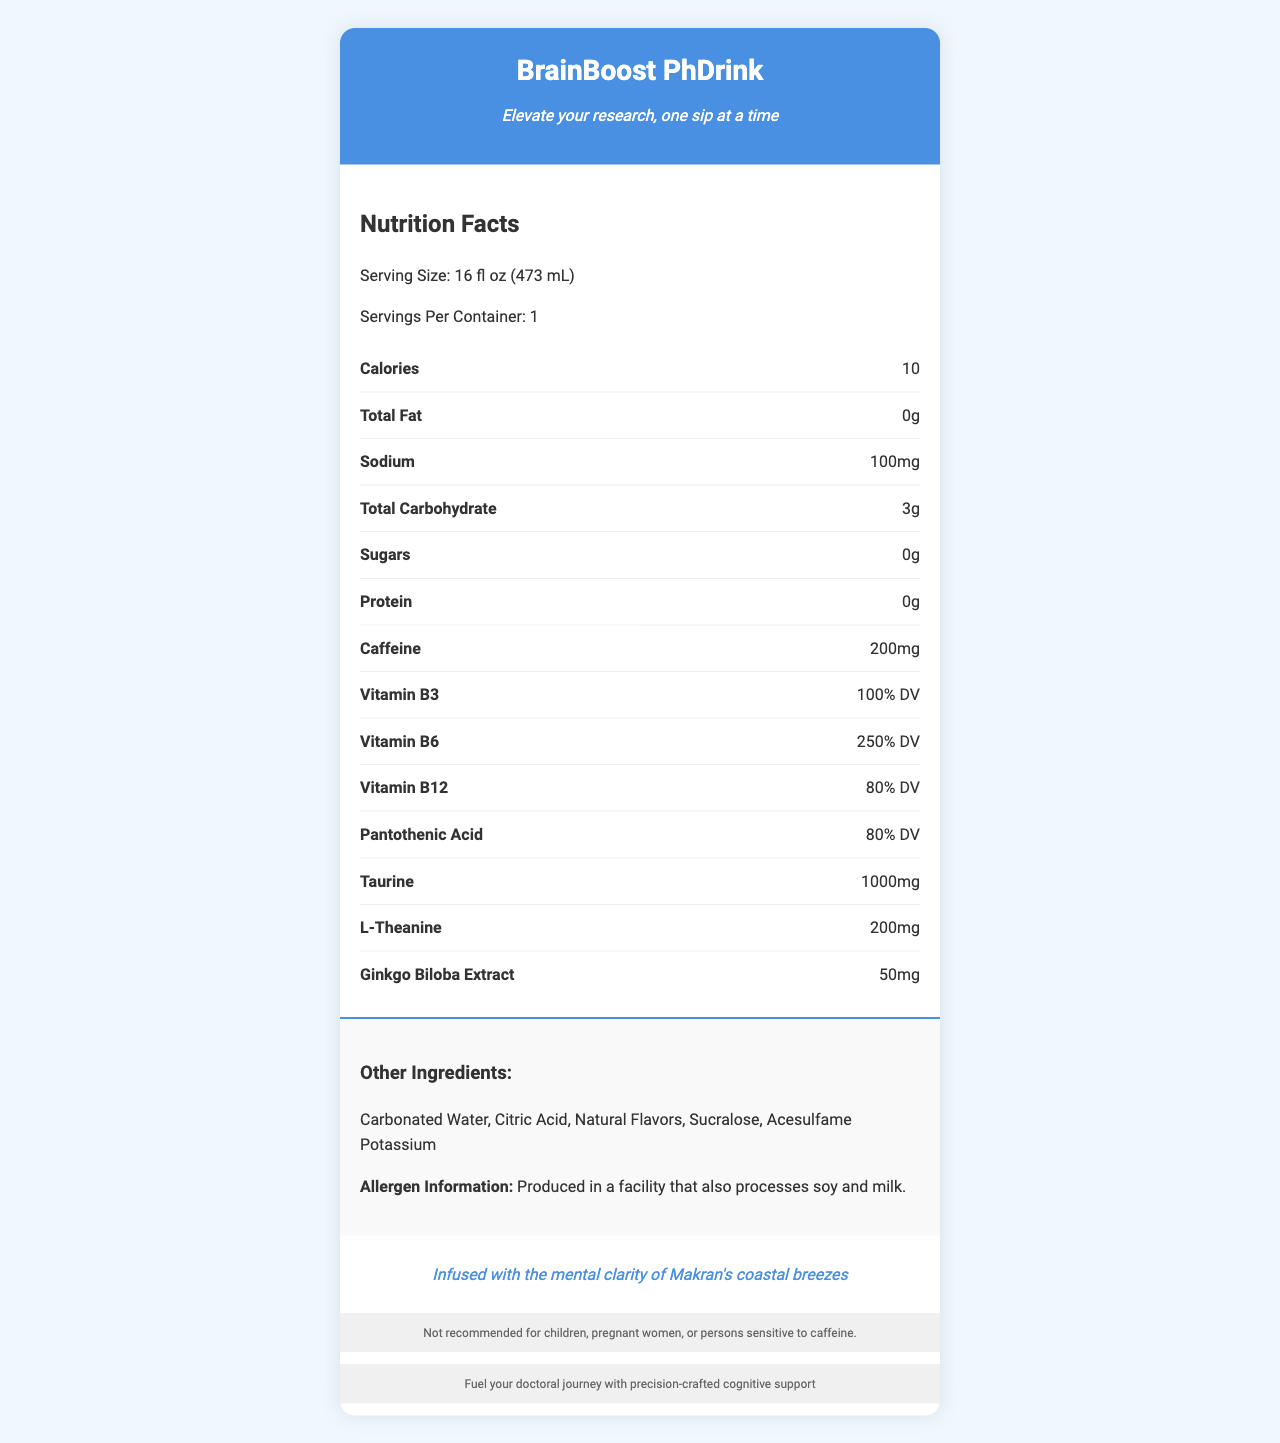what is the product name? The product name is clearly stated at the top of the document.
Answer: BrainBoost PhDrink how many servings are in one container? The document lists "Servings Per Container: 1".
Answer: 1 how much caffeine does one serving contain? Under the "Nutrition Facts", it is mentioned that there are "200mg" of caffeine.
Answer: 200mg what is the serving size for this product? The serving size is specified as "16 fl oz (473 mL)".
Answer: 16 fl oz (473 mL) what percentage of the daily value of Vitamin B6 does the product provide? The document states "Vitamin B6: 250% DV".
Answer: 250% how many calories are in one serving? The document lists "Calories: 10".
Answer: 10 what are the main ingredients in the product? The "Other Ingredients" section lists these ingredients.
Answer: Carbonated Water, Citric Acid, Natural Flavors, Sucralose, Acesulfame Potassium is this product recommended for children? The disclaimer at the bottom states "Not recommended for children".
Answer: No what are the vitamin B3 and B12 percentages of the daily value in this product? Both percentages are listed in the "Nutrition Facts" section.
Answer: Vitamin B3: 100% DV, Vitamin B12: 80% DV what should you be aware of regarding allergens? The allergen information specifies this under "Allergen Information".
Answer: Produced in a facility that also processes soy and milk. what unique ingredient is included in the product for mental clarity? The document lists "Ginkgo Biloba Extract" under the "Nutrition Facts".
Answer: Ginkgo Biloba Extract based on the document, who is the product marketed towards? The document includes marketing phrases such as "Fuel your doctoral journey with precision-crafted cognitive support".
Answer: PhD students what is the tagline of BrainBoost PhDrink? The tagline is written directly under the product name in the header.
Answer: Elevate your research, one sip at a time what is the unique element inspired by Makran culture in this product? This is mentioned as the "Makran Inspiration" at the bottom of the document.
Answer: Infused with the mental clarity of Makran's coastal breezes which of the following is not listed as an ingredient in BrainBoost PhDrink? A. Carbonated Water B. Sucralose C. High Fructose Corn Syrup D. Acesulfame Potassium High Fructose Corn Syrup is not listed in the "Other Ingredients" section.
Answer: C. High Fructose Corn Syrup how much sodium does one serving contain? A. 50mg B. 100mg C. 150mg D. 200mg It is listed as "Sodium: 100mg" in the "Nutrition Facts".
Answer: B. 100mg how would you summarize the main idea of this document? The document highlights the product's name, serving details, key ingredients, and marketing targeted towards doctoral students for mental clarity and support.
Answer: BrainBoost PhDrink is an energy drink designed to support PhD students with cognitive-enhancing ingredients like caffeine, B-vitamins, and Ginkgo Biloba Extract. It boasts low calories and zero sugars, providing focused energy "one sip at a time". did the document provide information on how to purchase the product? There is no information in the document about purchasing the product.
Answer: No how much taurine is included in each serving? The amount of taurine is specified as "1000mg" in the "Nutrition Facts".
Answer: 1000mg what's the ratio of total carbohydrates to protein in each serving? The "Nutrition Facts" section lists "Total Carbohydrate: 3g" and "Protein: 0g".
Answer: 3g to 0g is BrainBoost PhDrink free from any sugars? The sugars content is listed as "0g".
Answer: Yes how much l-theanine does each serving have? The "Nutrition Facts" section states "L-Theanine: 200mg".
Answer: 200mg 